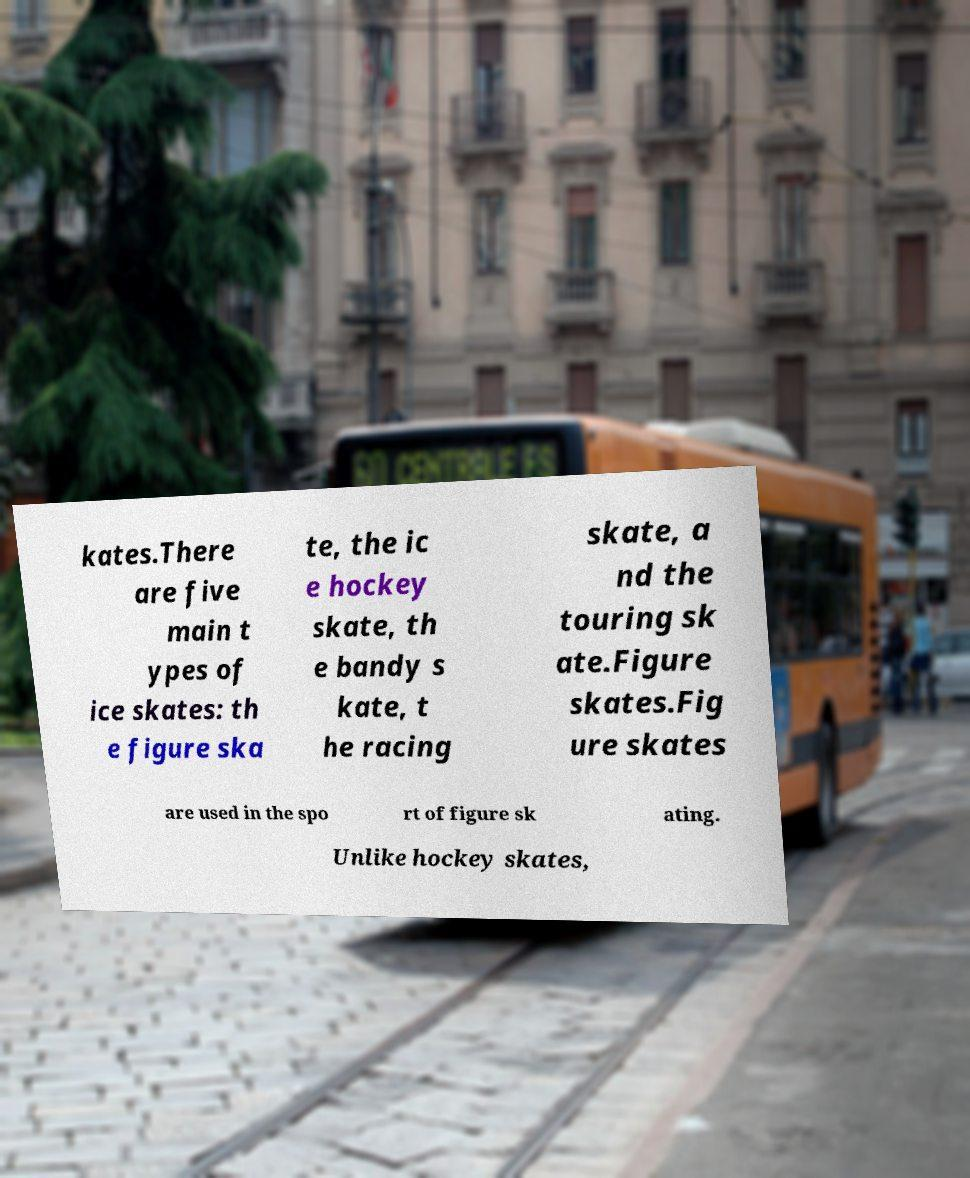Could you assist in decoding the text presented in this image and type it out clearly? kates.There are five main t ypes of ice skates: th e figure ska te, the ic e hockey skate, th e bandy s kate, t he racing skate, a nd the touring sk ate.Figure skates.Fig ure skates are used in the spo rt of figure sk ating. Unlike hockey skates, 